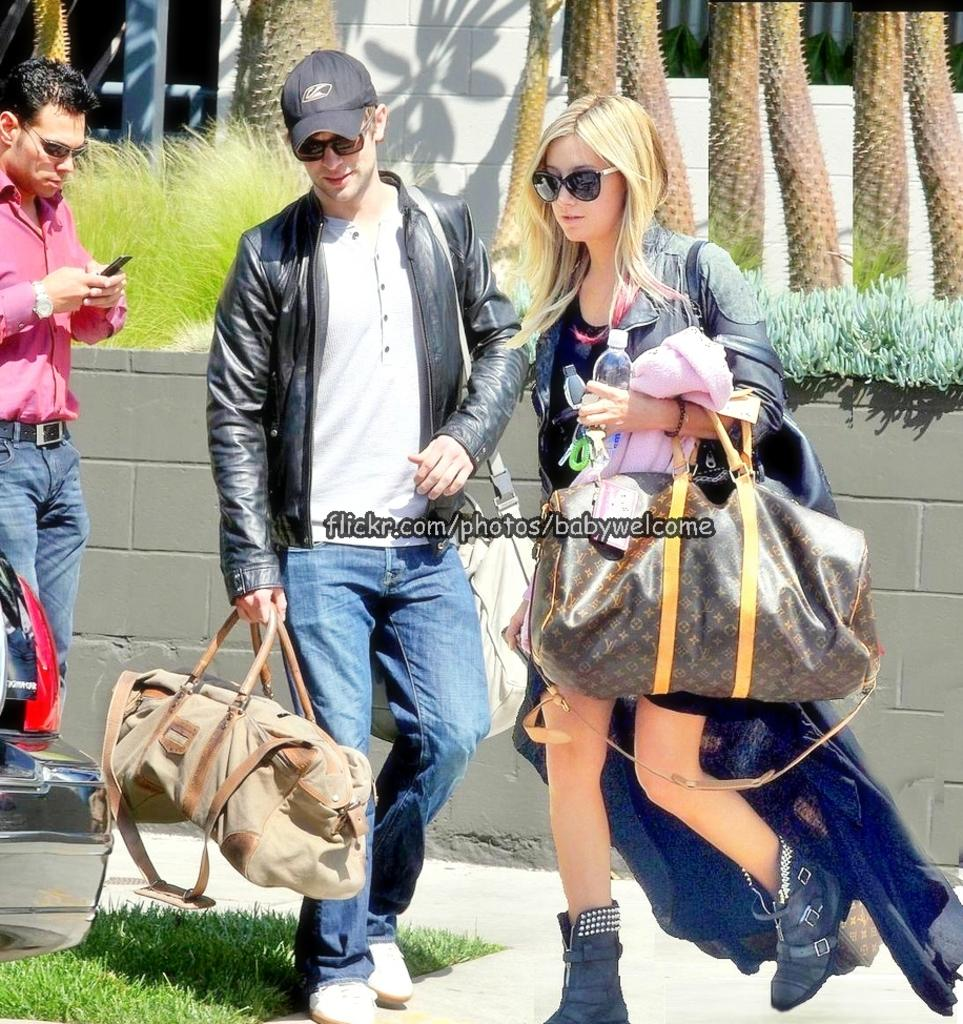How many people are present in the image? There are three people in the image: a woman, a man, and another person. What are the people in the image doing? The people are walking and holding their luggage. Are the people in the image interacting with each other? Yes, the people are holding hands in the image. What can be seen in the background of the image? There are trees and plants in the background of the image. What type of geese can be seen rolling in the image? There are no geese present in the image, and therefore no such activity can be observed. 